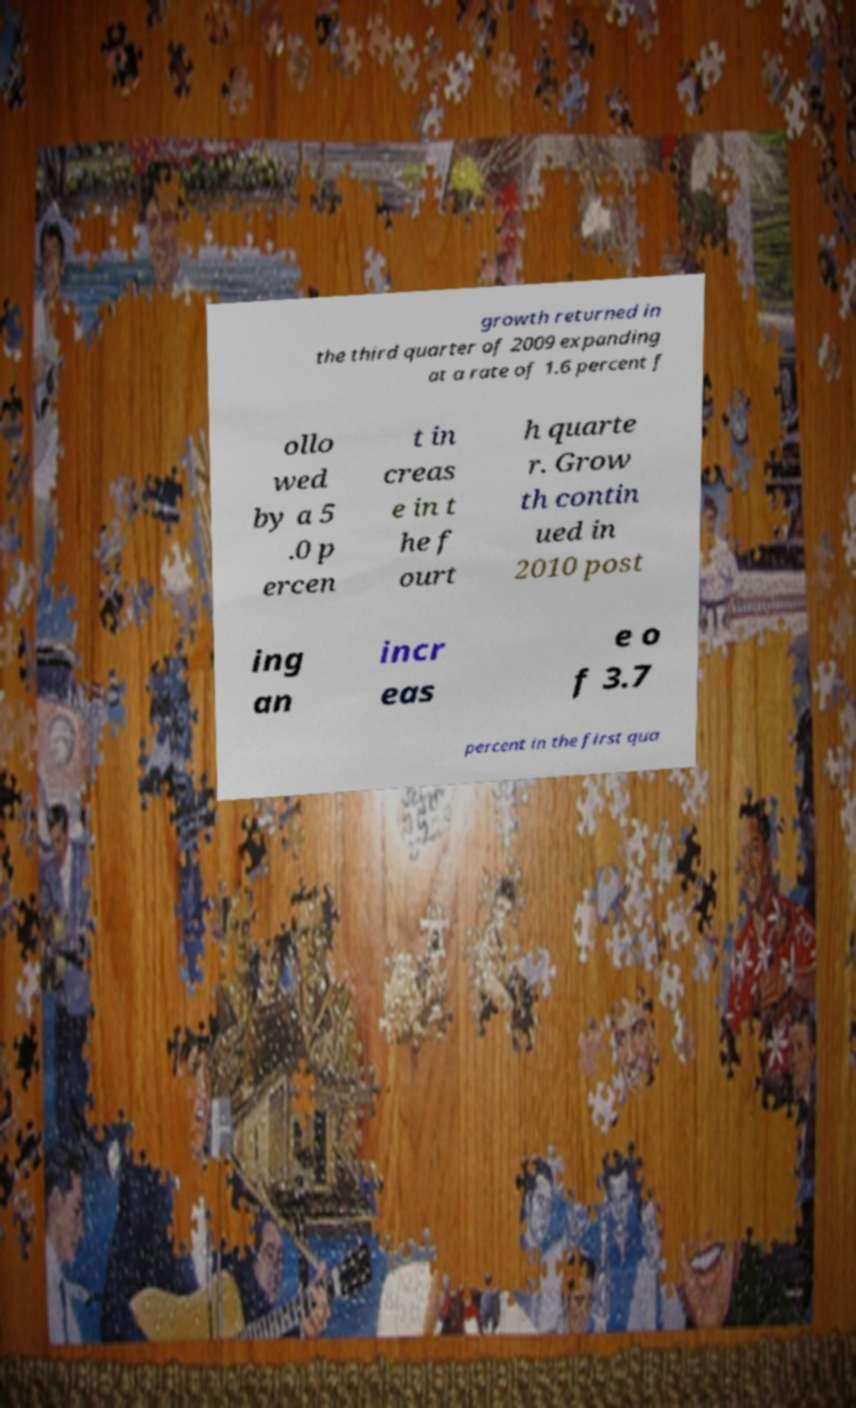There's text embedded in this image that I need extracted. Can you transcribe it verbatim? growth returned in the third quarter of 2009 expanding at a rate of 1.6 percent f ollo wed by a 5 .0 p ercen t in creas e in t he f ourt h quarte r. Grow th contin ued in 2010 post ing an incr eas e o f 3.7 percent in the first qua 